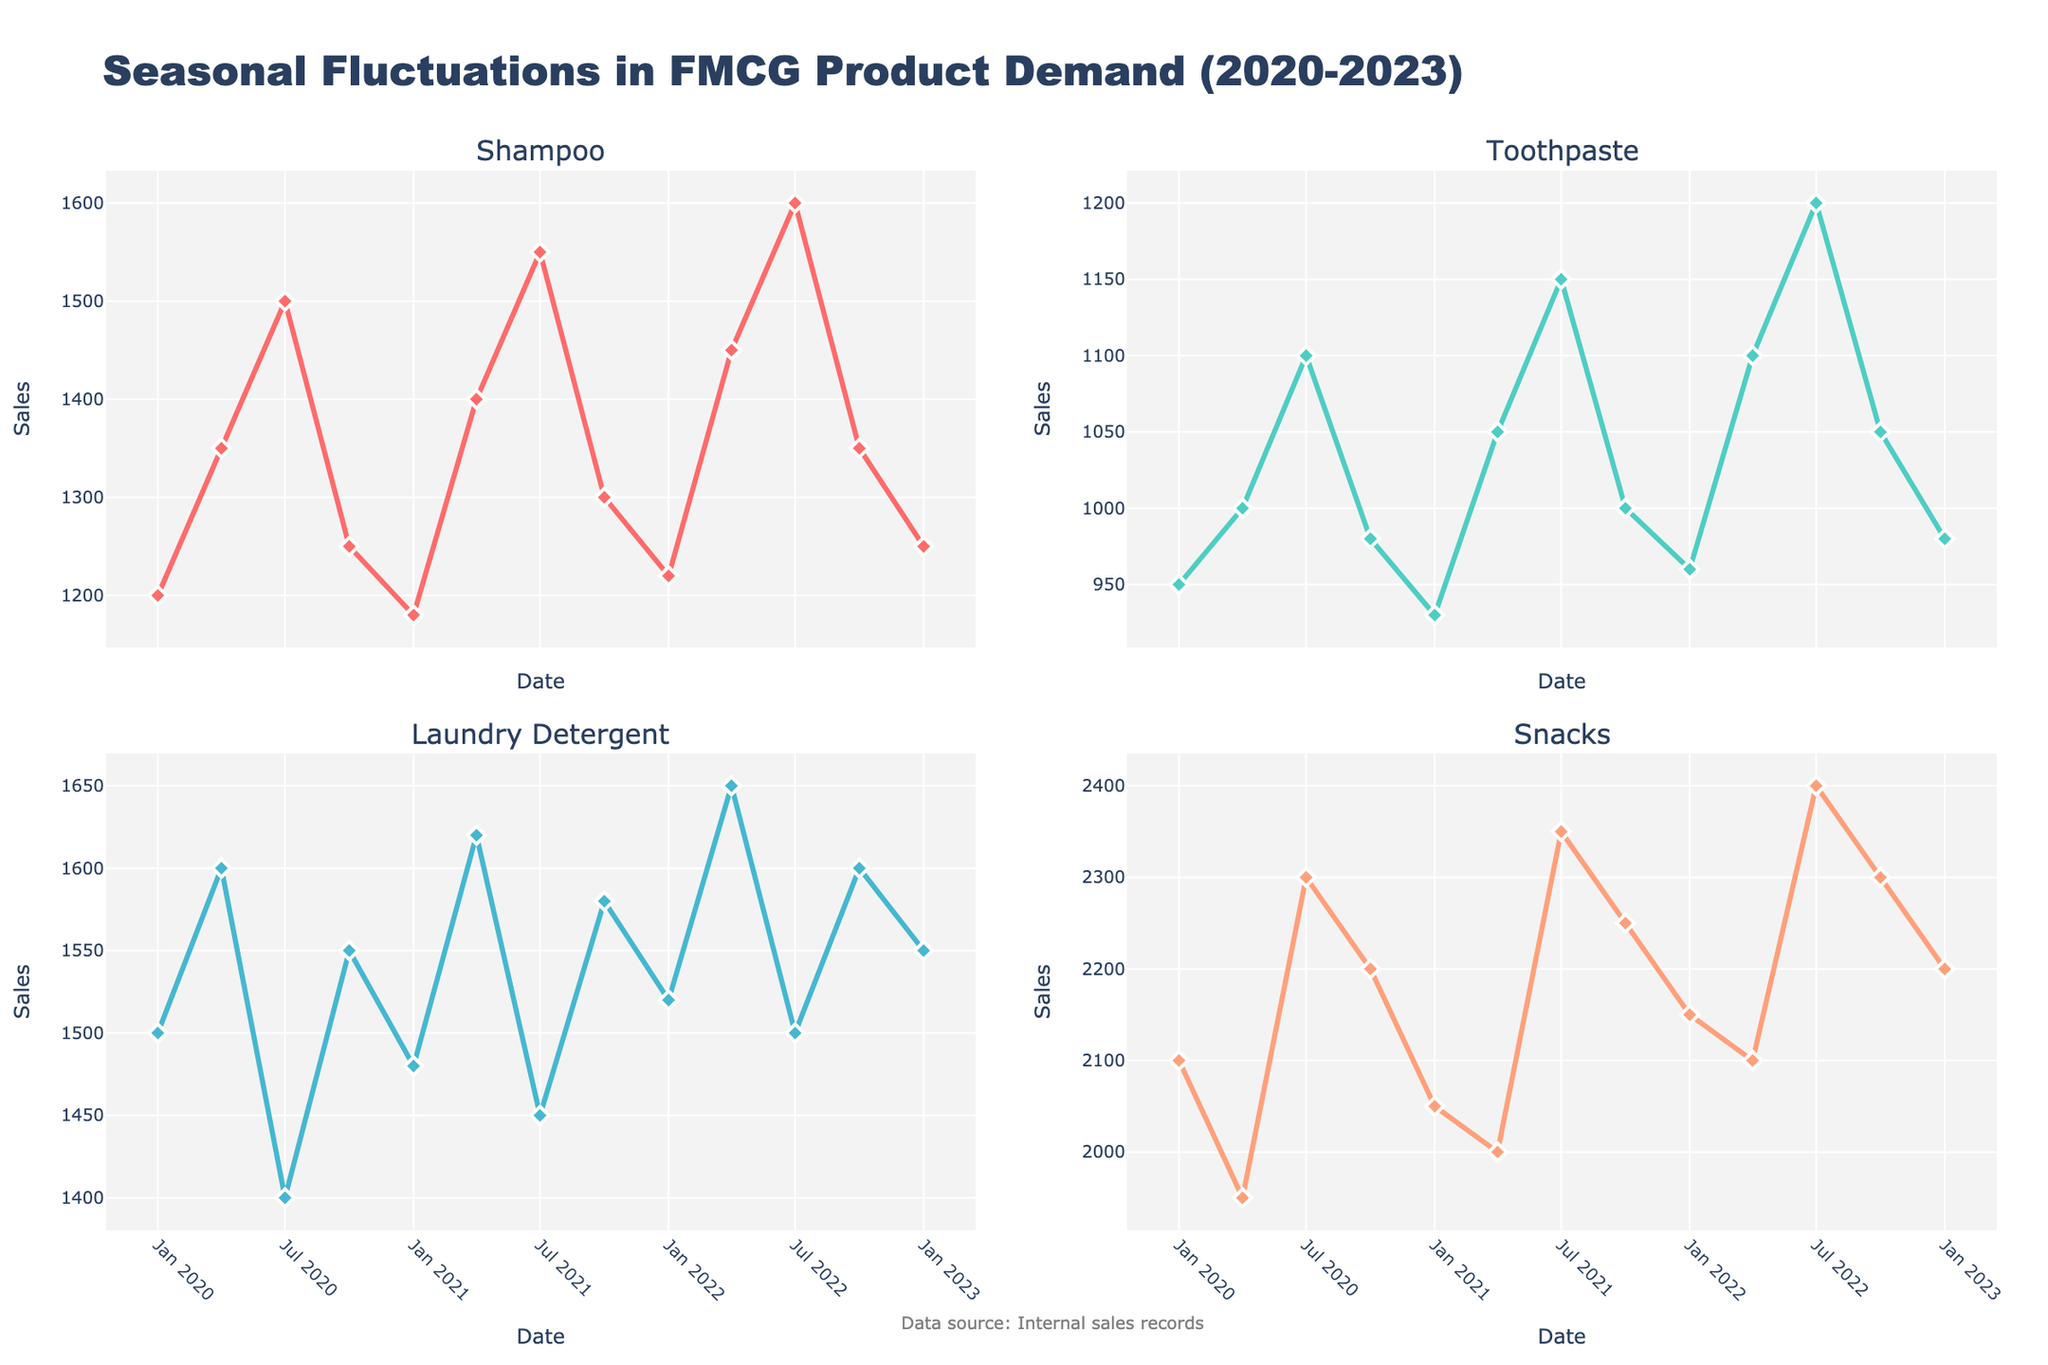What is the line color used for the Shampoo subplot? The figure has distinct line colors for each product. The Shampoo subplot's line is colored in a striking hue distinct from others.
Answer: Red What is the title of the overall figure? The figure's main title is displayed prominently at the top, summarizing and introducing the overall content.
Answer: Seasonal Fluctuations in FMCG Product Demand (2020-2023) Which product shows the highest sales in July 2022? From the subplots, observe the peaks in July 2022 for each product. The highest peak among them will indicate the product with the highest sales.
Answer: Snacks How many sales data points are plotted for each product line? Each subplot contains markers for the data points across the timeline, reflecting sales data collected at regular intervals. Count these points to find the answer.
Answer: 13 Which product had the most consistent sales over the period? Look for the product whose line graph shows the least fluctuation in sales values over the period. The more horizontal and smoother the line, the more consistent the sales.
Answer: Toothpaste Which two months have the highest sales difference for Laundry Detergent? Identify the peak and the lowest points in the Laundry Detergent subplot, then check the corresponding months for these extremities. Calculate the sales difference to confirm.
Answer: Apr 2020 and Jul 2020 Is there a seasonal pattern evident in the sales of Snacks? Assess the subplots for Snacks to see if there's a repeating pattern across the years in specific months. Check if a particular season shows consistent peaks or troughs.
Answer: Yes, peaks in July and October Did Shampoo sales increase or decrease from January 2020 to January 2023? Compare the sales data points for Shampoo in January of 2020 and January of 2023. The direction of the change (increase or decrease) is based on their relative values.
Answer: Increase Which product had the lowest sales in October 2022? Examine the sales values for October 2022 within each subplot. The product with the lowest value at that point can be identified as having the lowest sales.
Answer: Toothpaste What is the average number of sales for Shampoo from 2020 to 2023? Sum up all the sales values for Shampoo across the given months, then divide by the number of data points to get the average.
Answer: 1334 